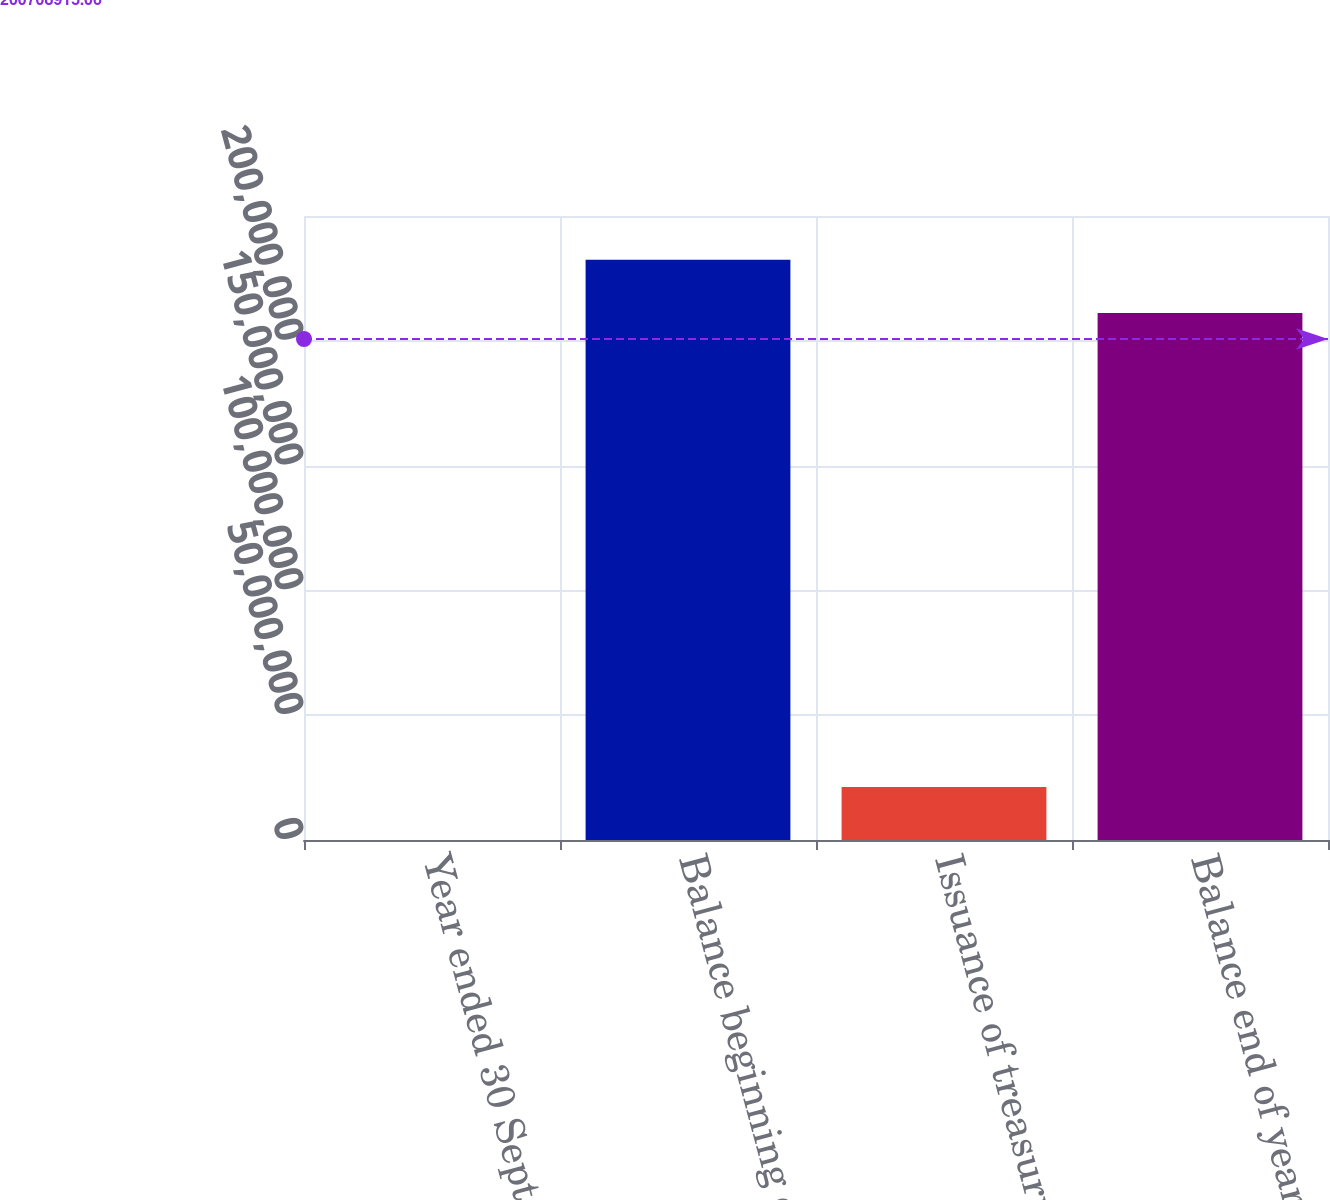Convert chart. <chart><loc_0><loc_0><loc_500><loc_500><bar_chart><fcel>Year ended 30 September<fcel>Balance beginning of year<fcel>Issuance of treasury shares<fcel>Balance end of year<nl><fcel>2013<fcel>2.32427e+08<fcel>2.12494e+07<fcel>2.11179e+08<nl></chart> 